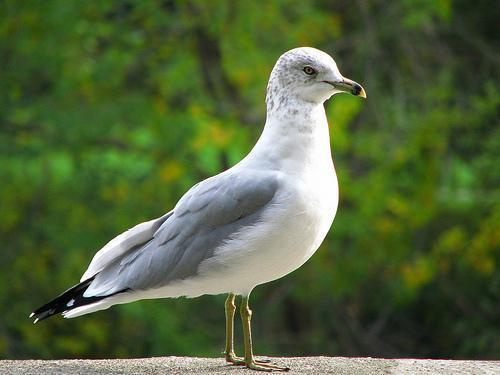How many birds are there?
Give a very brief answer. 1. 